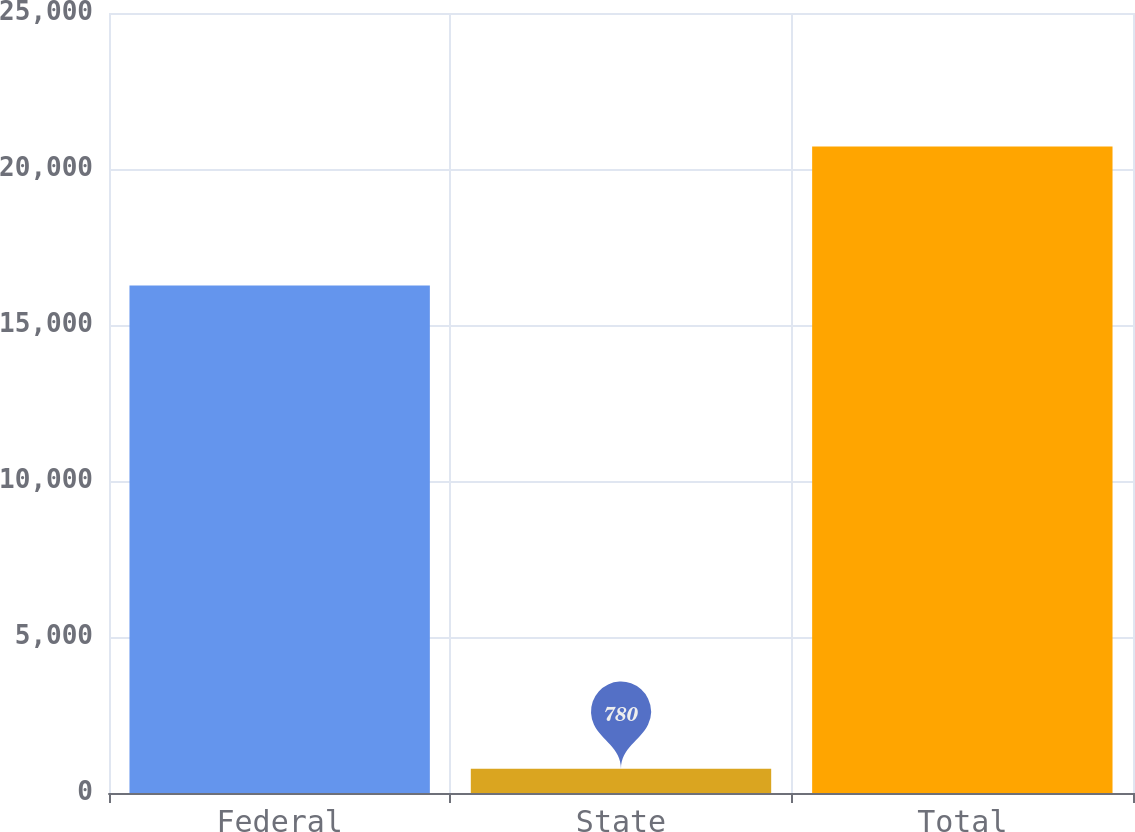Convert chart. <chart><loc_0><loc_0><loc_500><loc_500><bar_chart><fcel>Federal<fcel>State<fcel>Total<nl><fcel>16266<fcel>780<fcel>20725<nl></chart> 